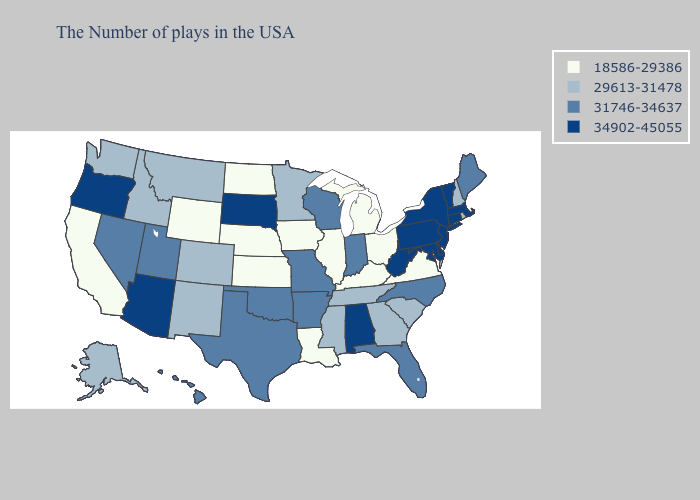Does New Hampshire have the lowest value in the USA?
Concise answer only. No. Among the states that border South Dakota , which have the lowest value?
Concise answer only. Iowa, Nebraska, North Dakota, Wyoming. Does Oregon have the highest value in the USA?
Short answer required. Yes. Which states have the lowest value in the USA?
Answer briefly. Virginia, Ohio, Michigan, Kentucky, Illinois, Louisiana, Iowa, Kansas, Nebraska, North Dakota, Wyoming, California. Among the states that border Kentucky , which have the highest value?
Write a very short answer. West Virginia. What is the highest value in states that border Massachusetts?
Quick response, please. 34902-45055. Name the states that have a value in the range 18586-29386?
Answer briefly. Virginia, Ohio, Michigan, Kentucky, Illinois, Louisiana, Iowa, Kansas, Nebraska, North Dakota, Wyoming, California. What is the lowest value in the West?
Be succinct. 18586-29386. Among the states that border Missouri , does Oklahoma have the lowest value?
Concise answer only. No. Which states hav the highest value in the MidWest?
Be succinct. South Dakota. What is the highest value in the West ?
Answer briefly. 34902-45055. Does New York have the highest value in the USA?
Quick response, please. Yes. Name the states that have a value in the range 34902-45055?
Answer briefly. Massachusetts, Vermont, Connecticut, New York, New Jersey, Delaware, Maryland, Pennsylvania, West Virginia, Alabama, South Dakota, Arizona, Oregon. Does Nebraska have the same value as New Jersey?
Short answer required. No. Name the states that have a value in the range 29613-31478?
Concise answer only. Rhode Island, New Hampshire, South Carolina, Georgia, Tennessee, Mississippi, Minnesota, Colorado, New Mexico, Montana, Idaho, Washington, Alaska. 